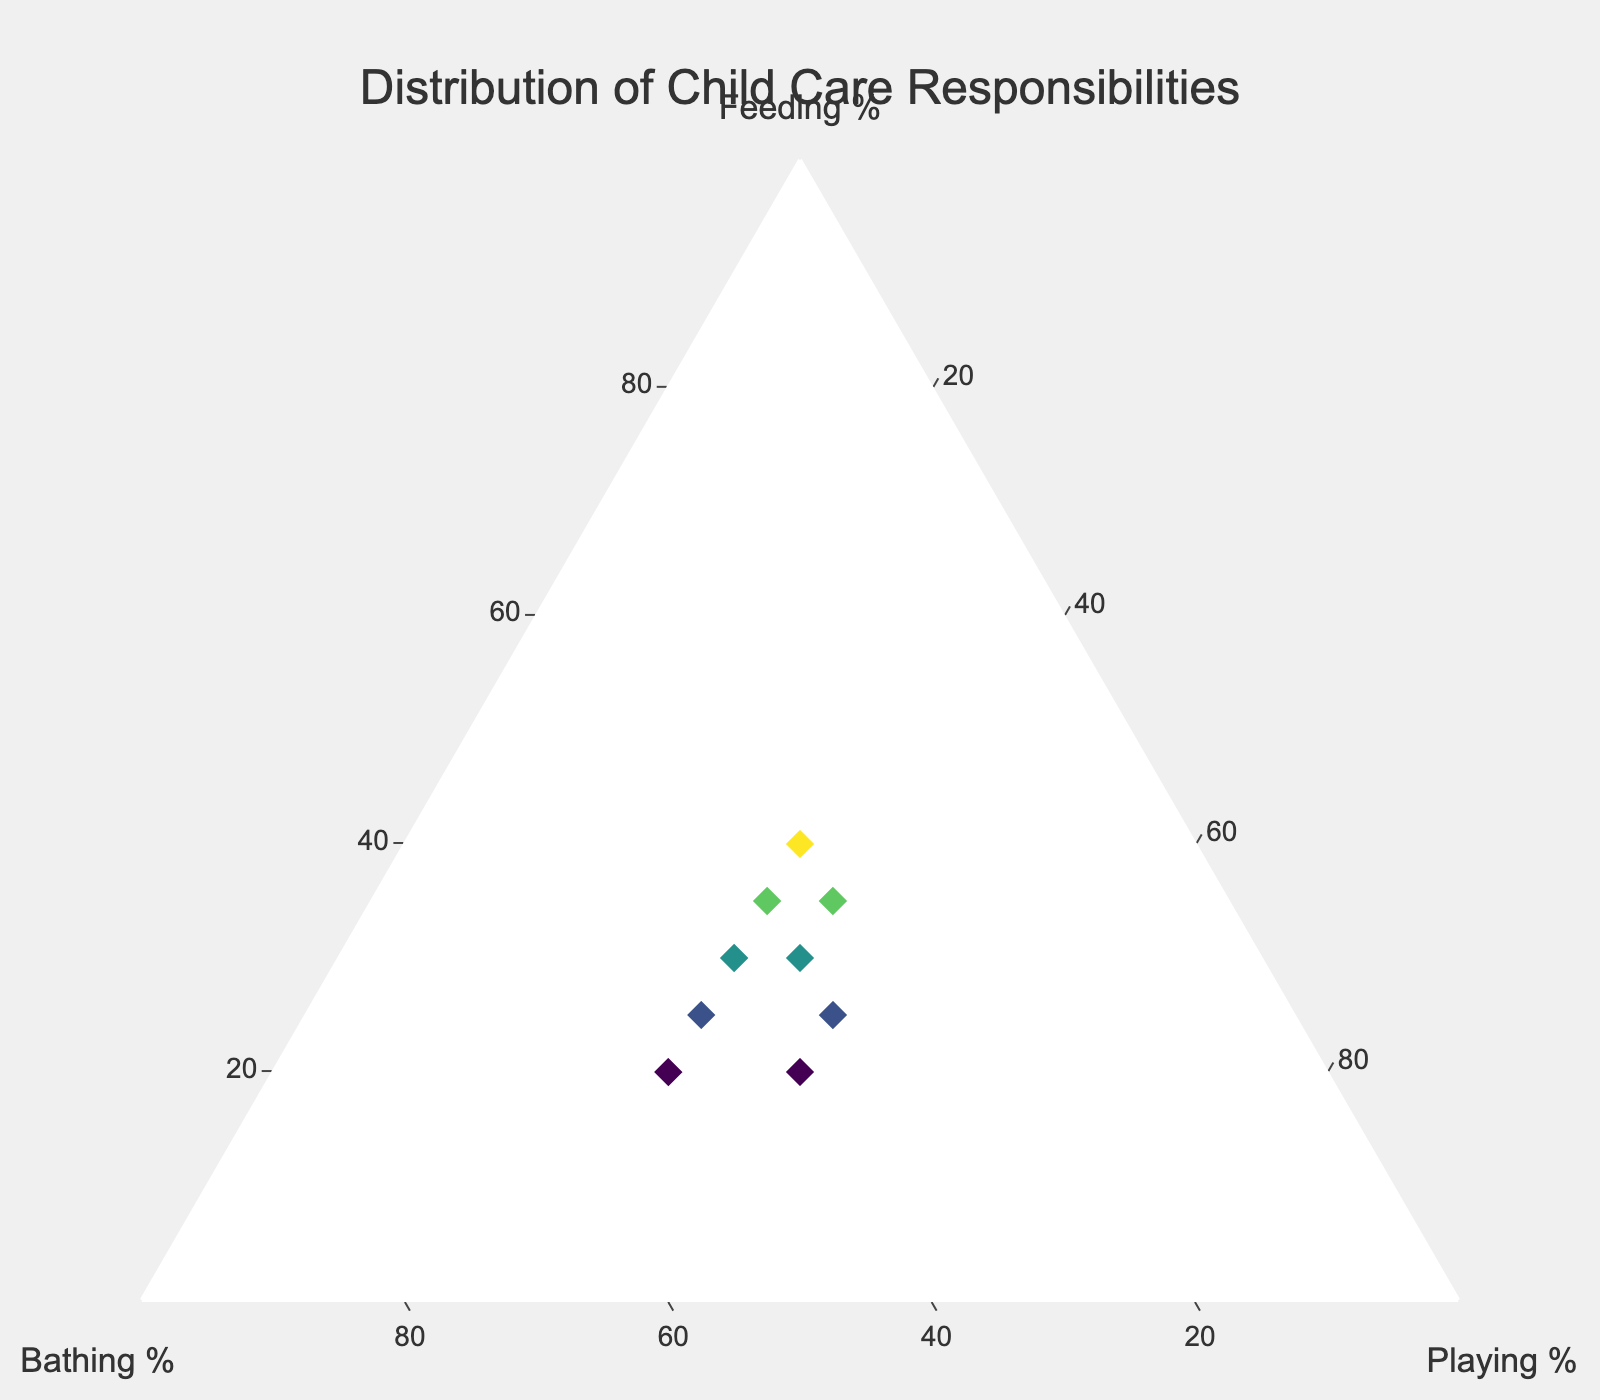How many data points are shown in the figure? We can see that each parent is represented by a marker on the plot, and the dataset lists 10 different parents, so there are 10 data points.
Answer: 10 Which parent spends the most percentage on feeding? By looking at the markers' hover text on the plot, we can see that Laura Wilson has the highest feeding percentage at 40%.
Answer: Laura Wilson What is the average percentage of bathing responsibilities among all parents? Add the percentages of bathing for every parent: 40 + 50 + 45 + 30 + 35 + 40 + 35 + 35 + 30 + 40 = 380. Divide by the number of parents (10): 380 / 10 = 38.
Answer: 38 Who spends equal time on feeding and playing? From the figure's hover text, we can see that Hannah Lee has equal percentages for feeding and playing, both at 35%.
Answer: Hannah Lee What is the range of playing percentages among the parents? From the figure, the playing percentages range from 30% to 40%. The highest value (40%) minus the lowest value (30%) gives a range of 10%.
Answer: 10 Which parent spends the most equal time across all three activities? Katie Davis has nearly equal shares of her time spent on feeding, bathing, and playing, with percentages of 35%, 35%, and 30%, respectively, making her contributions the most balanced.
Answer: Katie Davis Does any parent allocate more than 50% of their time to a single responsibility? By examining the data points, no parent allocates more than 50% of their time in any single responsibility, as the highest percentages are 50% for bathing by Mary Smith.
Answer: No Which parent has the same percentage for feeding and bathing responsibilities? According to the hover text, no parent has exactly the same percentage for both feeding and bathing responsibilities.
Answer: None What is the median percentage for the 'playing' responsibility? List the playing percentages in ascending order: 30, 30, 30, 30, 30, 35, 35, 35, 40, 40. With 10 data points, the median is the average of the 5th and 6th values: (30 + 35) / 2 = 32.5.
Answer: 32.5 